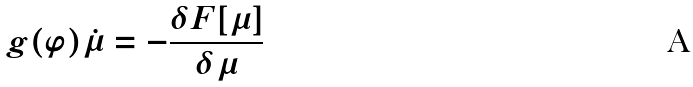<formula> <loc_0><loc_0><loc_500><loc_500>g ( \varphi ) \dot { \mu } = - \frac { \delta F [ \mu ] } { \delta \mu }</formula> 